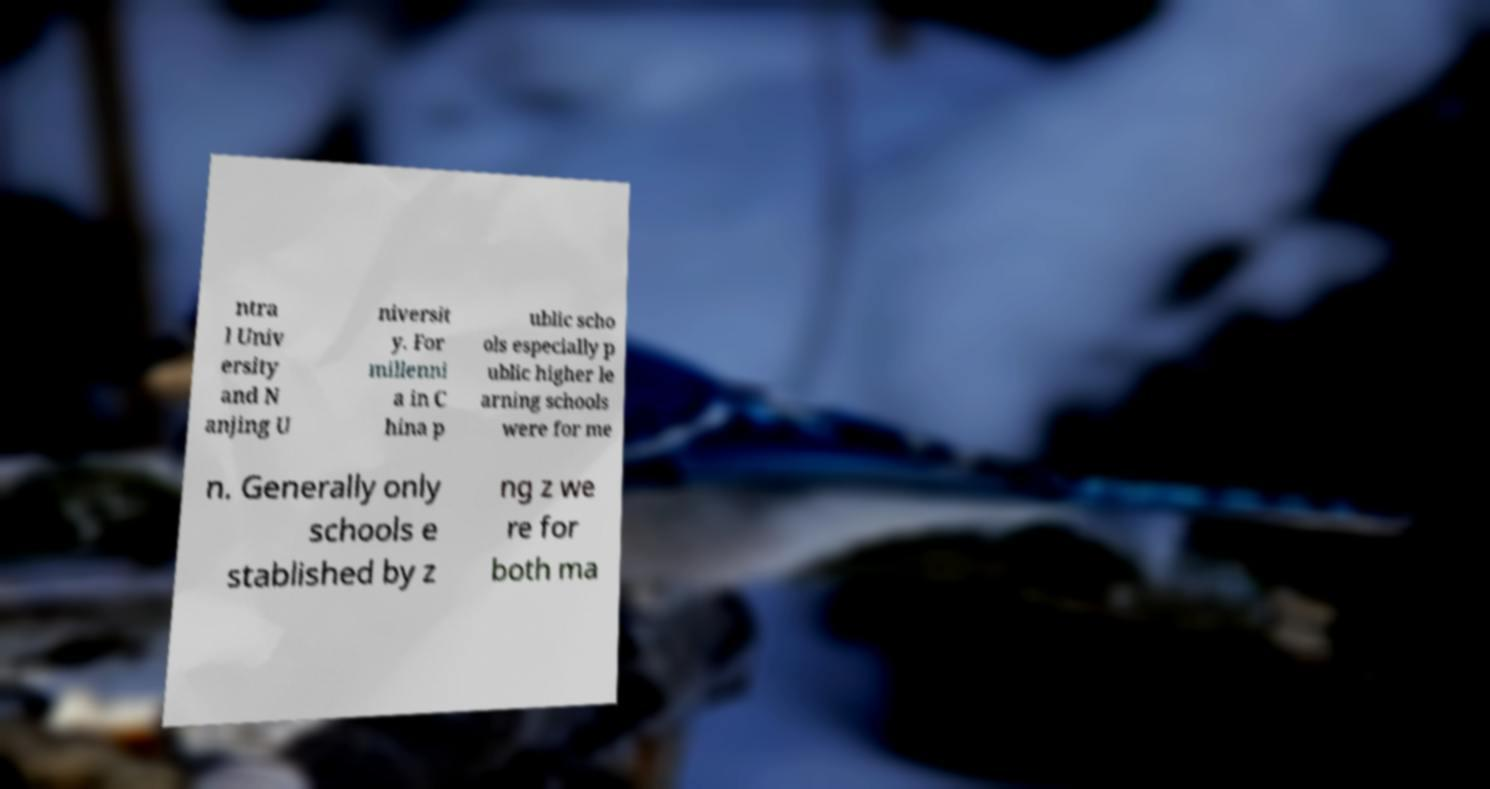I need the written content from this picture converted into text. Can you do that? ntra l Univ ersity and N anjing U niversit y. For millenni a in C hina p ublic scho ols especially p ublic higher le arning schools were for me n. Generally only schools e stablished by z ng z we re for both ma 